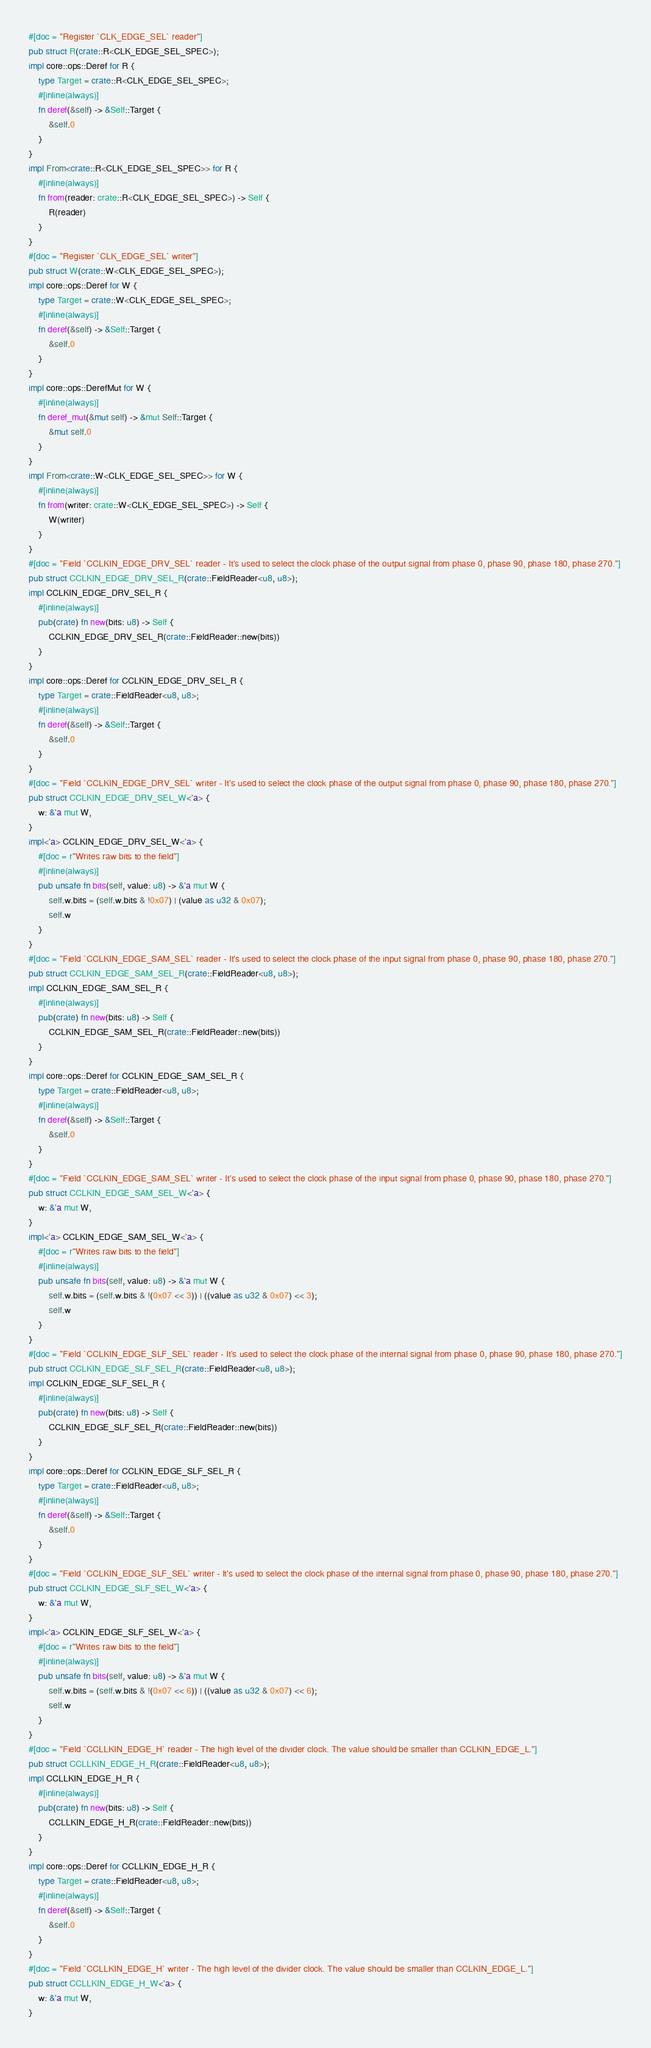<code> <loc_0><loc_0><loc_500><loc_500><_Rust_>#[doc = "Register `CLK_EDGE_SEL` reader"]
pub struct R(crate::R<CLK_EDGE_SEL_SPEC>);
impl core::ops::Deref for R {
    type Target = crate::R<CLK_EDGE_SEL_SPEC>;
    #[inline(always)]
    fn deref(&self) -> &Self::Target {
        &self.0
    }
}
impl From<crate::R<CLK_EDGE_SEL_SPEC>> for R {
    #[inline(always)]
    fn from(reader: crate::R<CLK_EDGE_SEL_SPEC>) -> Self {
        R(reader)
    }
}
#[doc = "Register `CLK_EDGE_SEL` writer"]
pub struct W(crate::W<CLK_EDGE_SEL_SPEC>);
impl core::ops::Deref for W {
    type Target = crate::W<CLK_EDGE_SEL_SPEC>;
    #[inline(always)]
    fn deref(&self) -> &Self::Target {
        &self.0
    }
}
impl core::ops::DerefMut for W {
    #[inline(always)]
    fn deref_mut(&mut self) -> &mut Self::Target {
        &mut self.0
    }
}
impl From<crate::W<CLK_EDGE_SEL_SPEC>> for W {
    #[inline(always)]
    fn from(writer: crate::W<CLK_EDGE_SEL_SPEC>) -> Self {
        W(writer)
    }
}
#[doc = "Field `CCLKIN_EDGE_DRV_SEL` reader - It's used to select the clock phase of the output signal from phase 0, phase 90, phase 180, phase 270."]
pub struct CCLKIN_EDGE_DRV_SEL_R(crate::FieldReader<u8, u8>);
impl CCLKIN_EDGE_DRV_SEL_R {
    #[inline(always)]
    pub(crate) fn new(bits: u8) -> Self {
        CCLKIN_EDGE_DRV_SEL_R(crate::FieldReader::new(bits))
    }
}
impl core::ops::Deref for CCLKIN_EDGE_DRV_SEL_R {
    type Target = crate::FieldReader<u8, u8>;
    #[inline(always)]
    fn deref(&self) -> &Self::Target {
        &self.0
    }
}
#[doc = "Field `CCLKIN_EDGE_DRV_SEL` writer - It's used to select the clock phase of the output signal from phase 0, phase 90, phase 180, phase 270."]
pub struct CCLKIN_EDGE_DRV_SEL_W<'a> {
    w: &'a mut W,
}
impl<'a> CCLKIN_EDGE_DRV_SEL_W<'a> {
    #[doc = r"Writes raw bits to the field"]
    #[inline(always)]
    pub unsafe fn bits(self, value: u8) -> &'a mut W {
        self.w.bits = (self.w.bits & !0x07) | (value as u32 & 0x07);
        self.w
    }
}
#[doc = "Field `CCLKIN_EDGE_SAM_SEL` reader - It's used to select the clock phase of the input signal from phase 0, phase 90, phase 180, phase 270."]
pub struct CCLKIN_EDGE_SAM_SEL_R(crate::FieldReader<u8, u8>);
impl CCLKIN_EDGE_SAM_SEL_R {
    #[inline(always)]
    pub(crate) fn new(bits: u8) -> Self {
        CCLKIN_EDGE_SAM_SEL_R(crate::FieldReader::new(bits))
    }
}
impl core::ops::Deref for CCLKIN_EDGE_SAM_SEL_R {
    type Target = crate::FieldReader<u8, u8>;
    #[inline(always)]
    fn deref(&self) -> &Self::Target {
        &self.0
    }
}
#[doc = "Field `CCLKIN_EDGE_SAM_SEL` writer - It's used to select the clock phase of the input signal from phase 0, phase 90, phase 180, phase 270."]
pub struct CCLKIN_EDGE_SAM_SEL_W<'a> {
    w: &'a mut W,
}
impl<'a> CCLKIN_EDGE_SAM_SEL_W<'a> {
    #[doc = r"Writes raw bits to the field"]
    #[inline(always)]
    pub unsafe fn bits(self, value: u8) -> &'a mut W {
        self.w.bits = (self.w.bits & !(0x07 << 3)) | ((value as u32 & 0x07) << 3);
        self.w
    }
}
#[doc = "Field `CCLKIN_EDGE_SLF_SEL` reader - It's used to select the clock phase of the internal signal from phase 0, phase 90, phase 180, phase 270."]
pub struct CCLKIN_EDGE_SLF_SEL_R(crate::FieldReader<u8, u8>);
impl CCLKIN_EDGE_SLF_SEL_R {
    #[inline(always)]
    pub(crate) fn new(bits: u8) -> Self {
        CCLKIN_EDGE_SLF_SEL_R(crate::FieldReader::new(bits))
    }
}
impl core::ops::Deref for CCLKIN_EDGE_SLF_SEL_R {
    type Target = crate::FieldReader<u8, u8>;
    #[inline(always)]
    fn deref(&self) -> &Self::Target {
        &self.0
    }
}
#[doc = "Field `CCLKIN_EDGE_SLF_SEL` writer - It's used to select the clock phase of the internal signal from phase 0, phase 90, phase 180, phase 270."]
pub struct CCLKIN_EDGE_SLF_SEL_W<'a> {
    w: &'a mut W,
}
impl<'a> CCLKIN_EDGE_SLF_SEL_W<'a> {
    #[doc = r"Writes raw bits to the field"]
    #[inline(always)]
    pub unsafe fn bits(self, value: u8) -> &'a mut W {
        self.w.bits = (self.w.bits & !(0x07 << 6)) | ((value as u32 & 0x07) << 6);
        self.w
    }
}
#[doc = "Field `CCLLKIN_EDGE_H` reader - The high level of the divider clock. The value should be smaller than CCLKIN_EDGE_L."]
pub struct CCLLKIN_EDGE_H_R(crate::FieldReader<u8, u8>);
impl CCLLKIN_EDGE_H_R {
    #[inline(always)]
    pub(crate) fn new(bits: u8) -> Self {
        CCLLKIN_EDGE_H_R(crate::FieldReader::new(bits))
    }
}
impl core::ops::Deref for CCLLKIN_EDGE_H_R {
    type Target = crate::FieldReader<u8, u8>;
    #[inline(always)]
    fn deref(&self) -> &Self::Target {
        &self.0
    }
}
#[doc = "Field `CCLLKIN_EDGE_H` writer - The high level of the divider clock. The value should be smaller than CCLKIN_EDGE_L."]
pub struct CCLLKIN_EDGE_H_W<'a> {
    w: &'a mut W,
}</code> 